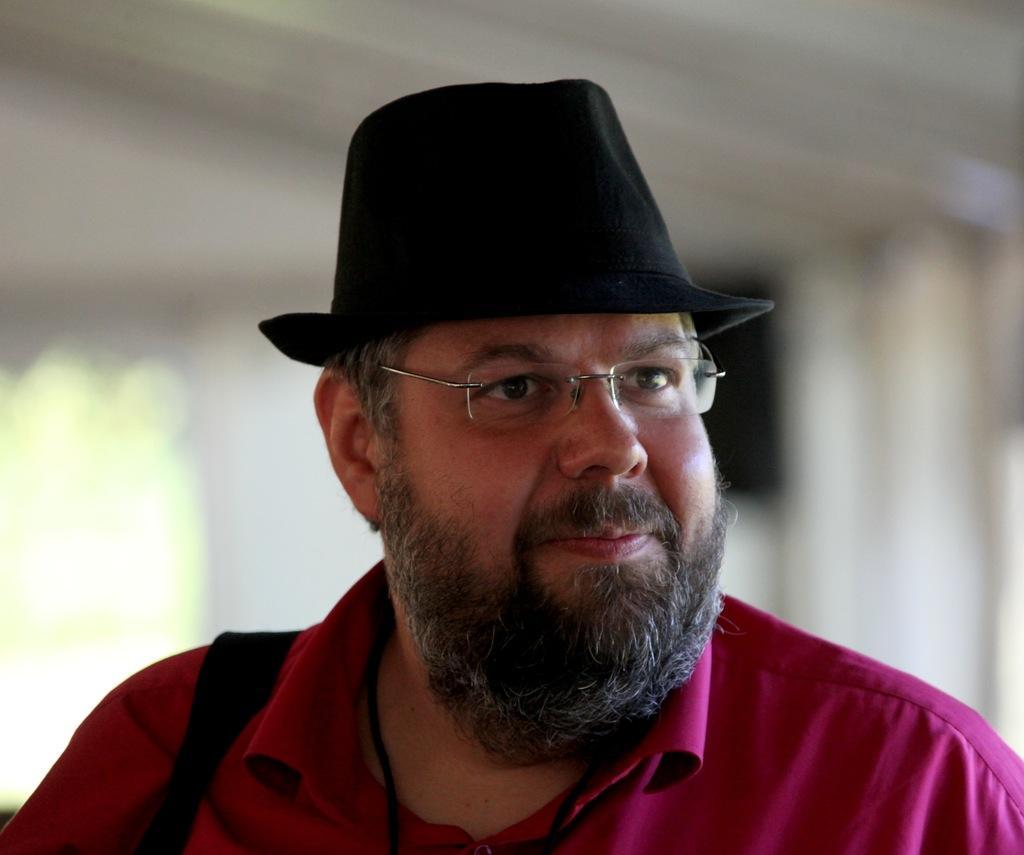How would you summarize this image in a sentence or two? In this image there is a person wearing spectacles and a cap. Background is blurry. 